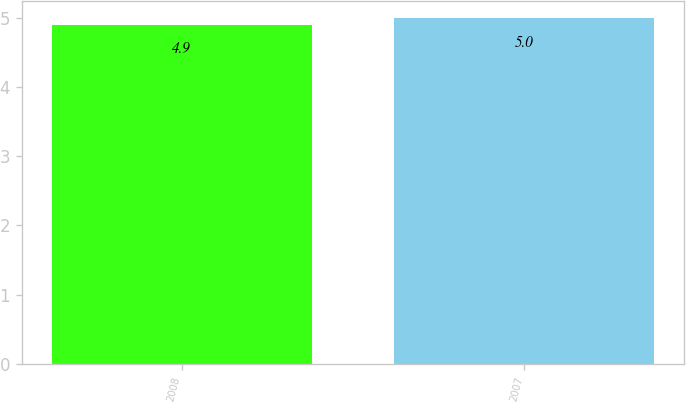Convert chart. <chart><loc_0><loc_0><loc_500><loc_500><bar_chart><fcel>2008<fcel>2007<nl><fcel>4.9<fcel>5<nl></chart> 